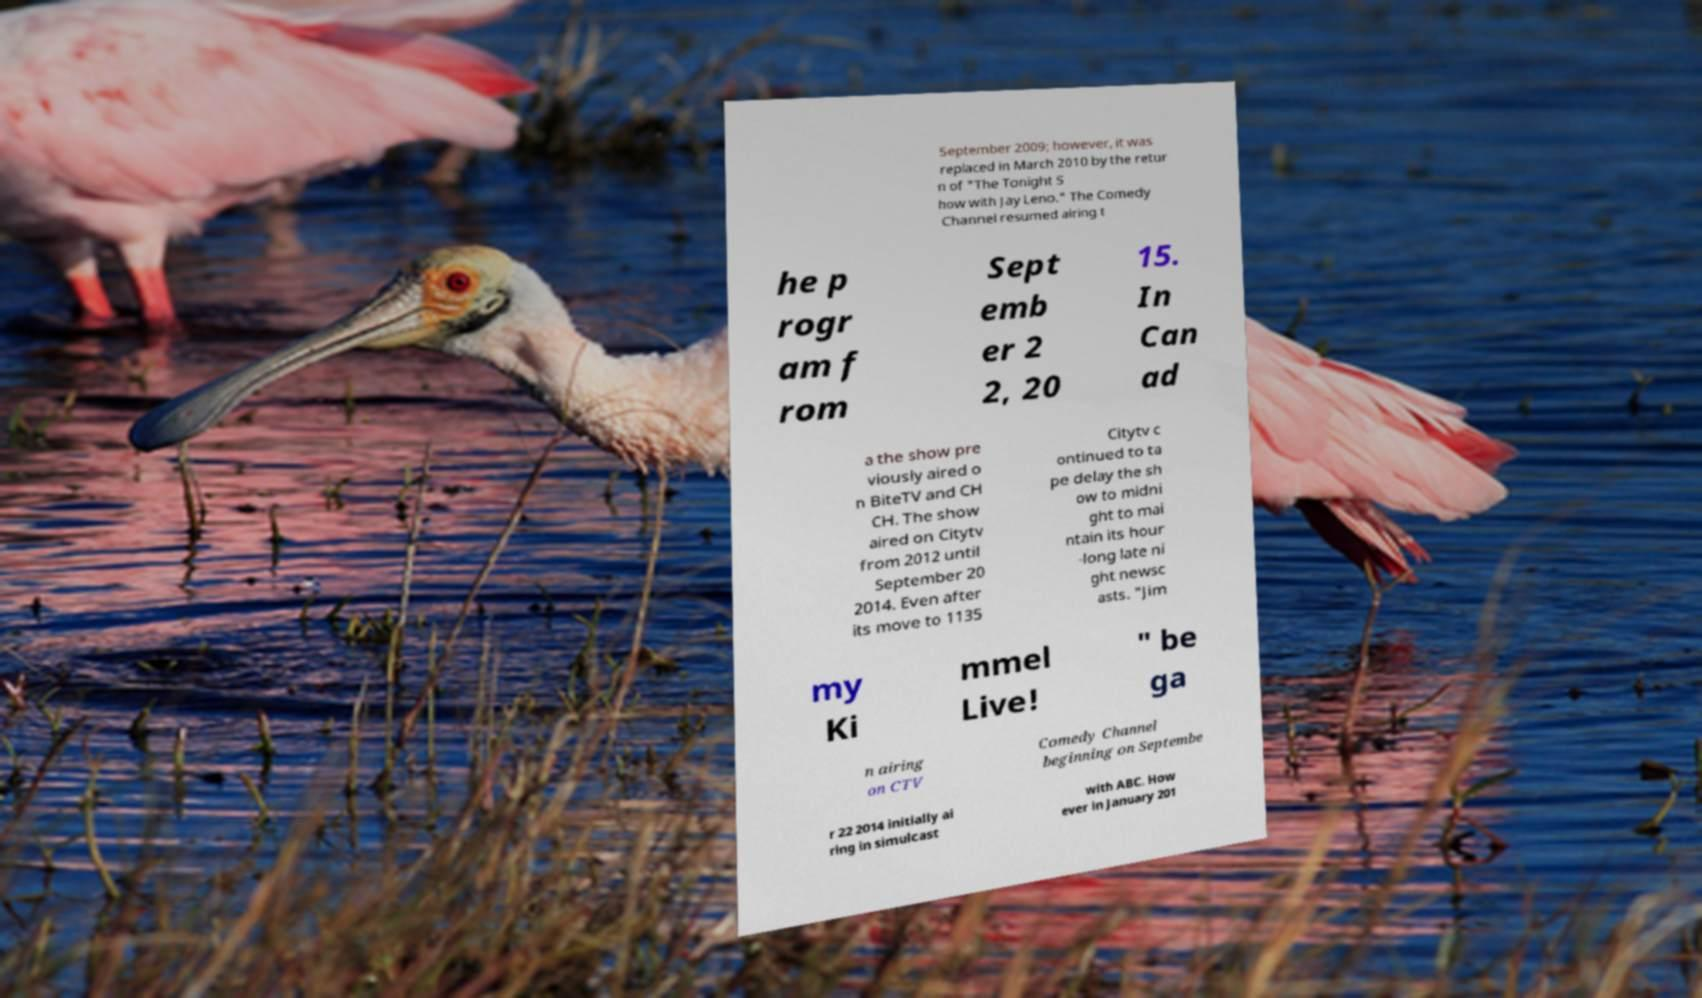There's text embedded in this image that I need extracted. Can you transcribe it verbatim? September 2009; however, it was replaced in March 2010 by the retur n of "The Tonight S how with Jay Leno." The Comedy Channel resumed airing t he p rogr am f rom Sept emb er 2 2, 20 15. In Can ad a the show pre viously aired o n BiteTV and CH CH. The show aired on Citytv from 2012 until September 20 2014. Even after its move to 1135 Citytv c ontinued to ta pe delay the sh ow to midni ght to mai ntain its hour -long late ni ght newsc asts. "Jim my Ki mmel Live! " be ga n airing on CTV Comedy Channel beginning on Septembe r 22 2014 initially ai ring in simulcast with ABC. How ever in January 201 